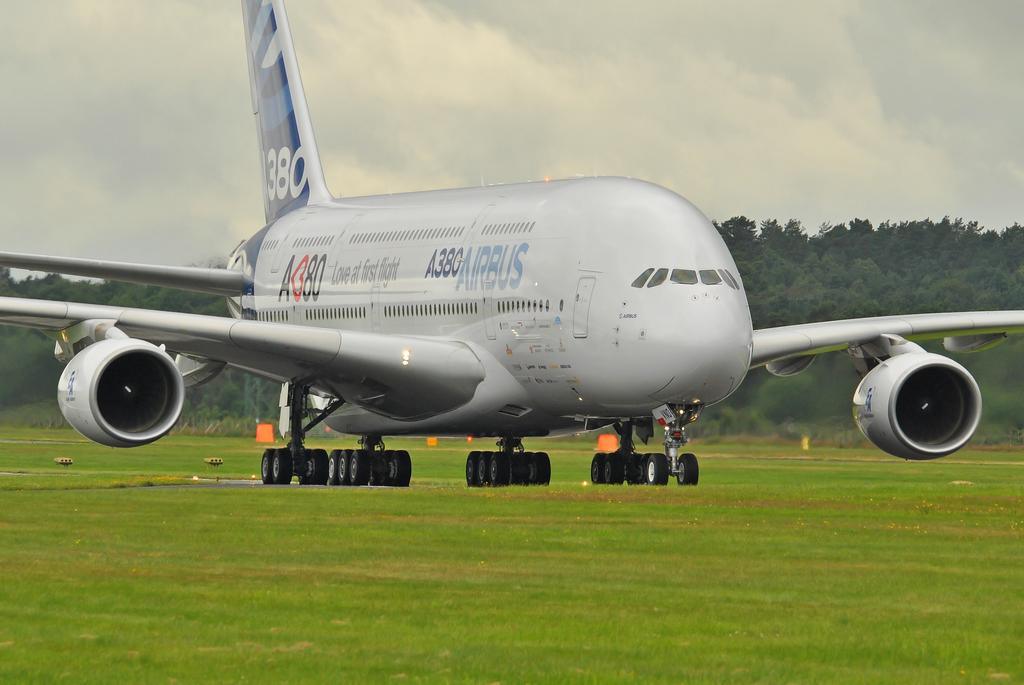What kind of plane is this?
Provide a short and direct response. Airbus. What is the model of the plane?
Provide a succinct answer. A380. 